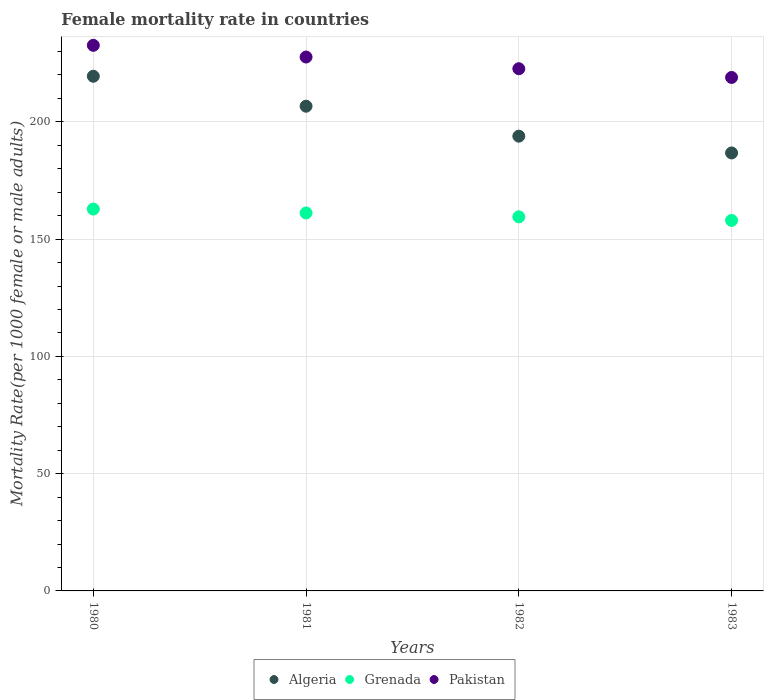Is the number of dotlines equal to the number of legend labels?
Your response must be concise. Yes. What is the female mortality rate in Algeria in 1980?
Offer a very short reply. 219.44. Across all years, what is the maximum female mortality rate in Pakistan?
Make the answer very short. 232.62. Across all years, what is the minimum female mortality rate in Algeria?
Provide a succinct answer. 186.74. In which year was the female mortality rate in Algeria maximum?
Ensure brevity in your answer.  1980. What is the total female mortality rate in Algeria in the graph?
Keep it short and to the point. 806.74. What is the difference between the female mortality rate in Grenada in 1981 and that in 1983?
Your answer should be very brief. 3.19. What is the difference between the female mortality rate in Grenada in 1981 and the female mortality rate in Algeria in 1980?
Make the answer very short. -58.28. What is the average female mortality rate in Grenada per year?
Provide a succinct answer. 160.36. In the year 1980, what is the difference between the female mortality rate in Algeria and female mortality rate in Grenada?
Offer a very short reply. 56.62. In how many years, is the female mortality rate in Pakistan greater than 90?
Provide a succinct answer. 4. What is the ratio of the female mortality rate in Grenada in 1980 to that in 1982?
Give a very brief answer. 1.02. What is the difference between the highest and the second highest female mortality rate in Grenada?
Make the answer very short. 1.66. What is the difference between the highest and the lowest female mortality rate in Grenada?
Make the answer very short. 4.84. In how many years, is the female mortality rate in Pakistan greater than the average female mortality rate in Pakistan taken over all years?
Your answer should be compact. 2. Is the sum of the female mortality rate in Grenada in 1980 and 1981 greater than the maximum female mortality rate in Algeria across all years?
Make the answer very short. Yes. Is it the case that in every year, the sum of the female mortality rate in Algeria and female mortality rate in Grenada  is greater than the female mortality rate in Pakistan?
Provide a succinct answer. Yes. Is the female mortality rate in Algeria strictly greater than the female mortality rate in Pakistan over the years?
Provide a succinct answer. No. How many years are there in the graph?
Your answer should be compact. 4. Are the values on the major ticks of Y-axis written in scientific E-notation?
Offer a very short reply. No. Does the graph contain any zero values?
Offer a terse response. No. Does the graph contain grids?
Offer a terse response. Yes. Where does the legend appear in the graph?
Give a very brief answer. Bottom center. How many legend labels are there?
Your response must be concise. 3. How are the legend labels stacked?
Keep it short and to the point. Horizontal. What is the title of the graph?
Give a very brief answer. Female mortality rate in countries. Does "China" appear as one of the legend labels in the graph?
Ensure brevity in your answer.  No. What is the label or title of the Y-axis?
Keep it short and to the point. Mortality Rate(per 1000 female or male adults). What is the Mortality Rate(per 1000 female or male adults) of Algeria in 1980?
Offer a terse response. 219.44. What is the Mortality Rate(per 1000 female or male adults) of Grenada in 1980?
Offer a very short reply. 162.81. What is the Mortality Rate(per 1000 female or male adults) in Pakistan in 1980?
Offer a very short reply. 232.62. What is the Mortality Rate(per 1000 female or male adults) in Algeria in 1981?
Provide a succinct answer. 206.67. What is the Mortality Rate(per 1000 female or male adults) in Grenada in 1981?
Provide a succinct answer. 161.16. What is the Mortality Rate(per 1000 female or male adults) of Pakistan in 1981?
Make the answer very short. 227.63. What is the Mortality Rate(per 1000 female or male adults) in Algeria in 1982?
Make the answer very short. 193.89. What is the Mortality Rate(per 1000 female or male adults) of Grenada in 1982?
Make the answer very short. 159.5. What is the Mortality Rate(per 1000 female or male adults) of Pakistan in 1982?
Keep it short and to the point. 222.65. What is the Mortality Rate(per 1000 female or male adults) in Algeria in 1983?
Keep it short and to the point. 186.74. What is the Mortality Rate(per 1000 female or male adults) in Grenada in 1983?
Give a very brief answer. 157.97. What is the Mortality Rate(per 1000 female or male adults) in Pakistan in 1983?
Your response must be concise. 218.93. Across all years, what is the maximum Mortality Rate(per 1000 female or male adults) of Algeria?
Your response must be concise. 219.44. Across all years, what is the maximum Mortality Rate(per 1000 female or male adults) in Grenada?
Your answer should be very brief. 162.81. Across all years, what is the maximum Mortality Rate(per 1000 female or male adults) of Pakistan?
Offer a terse response. 232.62. Across all years, what is the minimum Mortality Rate(per 1000 female or male adults) in Algeria?
Your response must be concise. 186.74. Across all years, what is the minimum Mortality Rate(per 1000 female or male adults) of Grenada?
Provide a succinct answer. 157.97. Across all years, what is the minimum Mortality Rate(per 1000 female or male adults) of Pakistan?
Ensure brevity in your answer.  218.93. What is the total Mortality Rate(per 1000 female or male adults) in Algeria in the graph?
Offer a terse response. 806.74. What is the total Mortality Rate(per 1000 female or male adults) in Grenada in the graph?
Your answer should be compact. 641.44. What is the total Mortality Rate(per 1000 female or male adults) of Pakistan in the graph?
Keep it short and to the point. 901.84. What is the difference between the Mortality Rate(per 1000 female or male adults) of Algeria in 1980 and that in 1981?
Make the answer very short. 12.77. What is the difference between the Mortality Rate(per 1000 female or male adults) in Grenada in 1980 and that in 1981?
Make the answer very short. 1.66. What is the difference between the Mortality Rate(per 1000 female or male adults) in Pakistan in 1980 and that in 1981?
Keep it short and to the point. 4.99. What is the difference between the Mortality Rate(per 1000 female or male adults) of Algeria in 1980 and that in 1982?
Ensure brevity in your answer.  25.55. What is the difference between the Mortality Rate(per 1000 female or male adults) of Grenada in 1980 and that in 1982?
Your answer should be very brief. 3.31. What is the difference between the Mortality Rate(per 1000 female or male adults) in Pakistan in 1980 and that in 1982?
Your answer should be compact. 9.97. What is the difference between the Mortality Rate(per 1000 female or male adults) of Algeria in 1980 and that in 1983?
Keep it short and to the point. 32.7. What is the difference between the Mortality Rate(per 1000 female or male adults) of Grenada in 1980 and that in 1983?
Provide a short and direct response. 4.84. What is the difference between the Mortality Rate(per 1000 female or male adults) in Pakistan in 1980 and that in 1983?
Give a very brief answer. 13.69. What is the difference between the Mortality Rate(per 1000 female or male adults) of Algeria in 1981 and that in 1982?
Your response must be concise. 12.77. What is the difference between the Mortality Rate(per 1000 female or male adults) of Grenada in 1981 and that in 1982?
Your answer should be compact. 1.66. What is the difference between the Mortality Rate(per 1000 female or male adults) of Pakistan in 1981 and that in 1982?
Give a very brief answer. 4.99. What is the difference between the Mortality Rate(per 1000 female or male adults) of Algeria in 1981 and that in 1983?
Give a very brief answer. 19.93. What is the difference between the Mortality Rate(per 1000 female or male adults) in Grenada in 1981 and that in 1983?
Make the answer very short. 3.19. What is the difference between the Mortality Rate(per 1000 female or male adults) of Pakistan in 1981 and that in 1983?
Provide a short and direct response. 8.7. What is the difference between the Mortality Rate(per 1000 female or male adults) in Algeria in 1982 and that in 1983?
Your response must be concise. 7.16. What is the difference between the Mortality Rate(per 1000 female or male adults) of Grenada in 1982 and that in 1983?
Your response must be concise. 1.53. What is the difference between the Mortality Rate(per 1000 female or male adults) in Pakistan in 1982 and that in 1983?
Give a very brief answer. 3.72. What is the difference between the Mortality Rate(per 1000 female or male adults) in Algeria in 1980 and the Mortality Rate(per 1000 female or male adults) in Grenada in 1981?
Keep it short and to the point. 58.28. What is the difference between the Mortality Rate(per 1000 female or male adults) of Algeria in 1980 and the Mortality Rate(per 1000 female or male adults) of Pakistan in 1981?
Your response must be concise. -8.2. What is the difference between the Mortality Rate(per 1000 female or male adults) in Grenada in 1980 and the Mortality Rate(per 1000 female or male adults) in Pakistan in 1981?
Your answer should be compact. -64.82. What is the difference between the Mortality Rate(per 1000 female or male adults) of Algeria in 1980 and the Mortality Rate(per 1000 female or male adults) of Grenada in 1982?
Make the answer very short. 59.94. What is the difference between the Mortality Rate(per 1000 female or male adults) in Algeria in 1980 and the Mortality Rate(per 1000 female or male adults) in Pakistan in 1982?
Provide a short and direct response. -3.21. What is the difference between the Mortality Rate(per 1000 female or male adults) of Grenada in 1980 and the Mortality Rate(per 1000 female or male adults) of Pakistan in 1982?
Offer a very short reply. -59.83. What is the difference between the Mortality Rate(per 1000 female or male adults) in Algeria in 1980 and the Mortality Rate(per 1000 female or male adults) in Grenada in 1983?
Give a very brief answer. 61.47. What is the difference between the Mortality Rate(per 1000 female or male adults) in Algeria in 1980 and the Mortality Rate(per 1000 female or male adults) in Pakistan in 1983?
Your answer should be very brief. 0.51. What is the difference between the Mortality Rate(per 1000 female or male adults) of Grenada in 1980 and the Mortality Rate(per 1000 female or male adults) of Pakistan in 1983?
Offer a terse response. -56.12. What is the difference between the Mortality Rate(per 1000 female or male adults) of Algeria in 1981 and the Mortality Rate(per 1000 female or male adults) of Grenada in 1982?
Your response must be concise. 47.16. What is the difference between the Mortality Rate(per 1000 female or male adults) of Algeria in 1981 and the Mortality Rate(per 1000 female or male adults) of Pakistan in 1982?
Make the answer very short. -15.98. What is the difference between the Mortality Rate(per 1000 female or male adults) of Grenada in 1981 and the Mortality Rate(per 1000 female or male adults) of Pakistan in 1982?
Offer a terse response. -61.49. What is the difference between the Mortality Rate(per 1000 female or male adults) in Algeria in 1981 and the Mortality Rate(per 1000 female or male adults) in Grenada in 1983?
Keep it short and to the point. 48.7. What is the difference between the Mortality Rate(per 1000 female or male adults) of Algeria in 1981 and the Mortality Rate(per 1000 female or male adults) of Pakistan in 1983?
Provide a succinct answer. -12.27. What is the difference between the Mortality Rate(per 1000 female or male adults) in Grenada in 1981 and the Mortality Rate(per 1000 female or male adults) in Pakistan in 1983?
Offer a terse response. -57.77. What is the difference between the Mortality Rate(per 1000 female or male adults) of Algeria in 1982 and the Mortality Rate(per 1000 female or male adults) of Grenada in 1983?
Your answer should be compact. 35.92. What is the difference between the Mortality Rate(per 1000 female or male adults) of Algeria in 1982 and the Mortality Rate(per 1000 female or male adults) of Pakistan in 1983?
Offer a terse response. -25.04. What is the difference between the Mortality Rate(per 1000 female or male adults) in Grenada in 1982 and the Mortality Rate(per 1000 female or male adults) in Pakistan in 1983?
Offer a terse response. -59.43. What is the average Mortality Rate(per 1000 female or male adults) in Algeria per year?
Provide a short and direct response. 201.68. What is the average Mortality Rate(per 1000 female or male adults) in Grenada per year?
Provide a succinct answer. 160.36. What is the average Mortality Rate(per 1000 female or male adults) in Pakistan per year?
Keep it short and to the point. 225.46. In the year 1980, what is the difference between the Mortality Rate(per 1000 female or male adults) in Algeria and Mortality Rate(per 1000 female or male adults) in Grenada?
Make the answer very short. 56.62. In the year 1980, what is the difference between the Mortality Rate(per 1000 female or male adults) in Algeria and Mortality Rate(per 1000 female or male adults) in Pakistan?
Offer a terse response. -13.18. In the year 1980, what is the difference between the Mortality Rate(per 1000 female or male adults) in Grenada and Mortality Rate(per 1000 female or male adults) in Pakistan?
Offer a terse response. -69.81. In the year 1981, what is the difference between the Mortality Rate(per 1000 female or male adults) in Algeria and Mortality Rate(per 1000 female or male adults) in Grenada?
Give a very brief answer. 45.51. In the year 1981, what is the difference between the Mortality Rate(per 1000 female or male adults) of Algeria and Mortality Rate(per 1000 female or male adults) of Pakistan?
Make the answer very short. -20.97. In the year 1981, what is the difference between the Mortality Rate(per 1000 female or male adults) in Grenada and Mortality Rate(per 1000 female or male adults) in Pakistan?
Your answer should be compact. -66.48. In the year 1982, what is the difference between the Mortality Rate(per 1000 female or male adults) of Algeria and Mortality Rate(per 1000 female or male adults) of Grenada?
Make the answer very short. 34.39. In the year 1982, what is the difference between the Mortality Rate(per 1000 female or male adults) of Algeria and Mortality Rate(per 1000 female or male adults) of Pakistan?
Provide a succinct answer. -28.75. In the year 1982, what is the difference between the Mortality Rate(per 1000 female or male adults) in Grenada and Mortality Rate(per 1000 female or male adults) in Pakistan?
Keep it short and to the point. -63.15. In the year 1983, what is the difference between the Mortality Rate(per 1000 female or male adults) in Algeria and Mortality Rate(per 1000 female or male adults) in Grenada?
Provide a succinct answer. 28.77. In the year 1983, what is the difference between the Mortality Rate(per 1000 female or male adults) of Algeria and Mortality Rate(per 1000 female or male adults) of Pakistan?
Your answer should be very brief. -32.19. In the year 1983, what is the difference between the Mortality Rate(per 1000 female or male adults) in Grenada and Mortality Rate(per 1000 female or male adults) in Pakistan?
Provide a succinct answer. -60.96. What is the ratio of the Mortality Rate(per 1000 female or male adults) in Algeria in 1980 to that in 1981?
Your answer should be very brief. 1.06. What is the ratio of the Mortality Rate(per 1000 female or male adults) in Grenada in 1980 to that in 1981?
Keep it short and to the point. 1.01. What is the ratio of the Mortality Rate(per 1000 female or male adults) of Pakistan in 1980 to that in 1981?
Your answer should be very brief. 1.02. What is the ratio of the Mortality Rate(per 1000 female or male adults) of Algeria in 1980 to that in 1982?
Your answer should be compact. 1.13. What is the ratio of the Mortality Rate(per 1000 female or male adults) of Grenada in 1980 to that in 1982?
Make the answer very short. 1.02. What is the ratio of the Mortality Rate(per 1000 female or male adults) of Pakistan in 1980 to that in 1982?
Your answer should be very brief. 1.04. What is the ratio of the Mortality Rate(per 1000 female or male adults) in Algeria in 1980 to that in 1983?
Provide a succinct answer. 1.18. What is the ratio of the Mortality Rate(per 1000 female or male adults) of Grenada in 1980 to that in 1983?
Keep it short and to the point. 1.03. What is the ratio of the Mortality Rate(per 1000 female or male adults) of Algeria in 1981 to that in 1982?
Your answer should be very brief. 1.07. What is the ratio of the Mortality Rate(per 1000 female or male adults) in Grenada in 1981 to that in 1982?
Offer a terse response. 1.01. What is the ratio of the Mortality Rate(per 1000 female or male adults) of Pakistan in 1981 to that in 1982?
Provide a succinct answer. 1.02. What is the ratio of the Mortality Rate(per 1000 female or male adults) of Algeria in 1981 to that in 1983?
Ensure brevity in your answer.  1.11. What is the ratio of the Mortality Rate(per 1000 female or male adults) of Grenada in 1981 to that in 1983?
Offer a very short reply. 1.02. What is the ratio of the Mortality Rate(per 1000 female or male adults) of Pakistan in 1981 to that in 1983?
Make the answer very short. 1.04. What is the ratio of the Mortality Rate(per 1000 female or male adults) of Algeria in 1982 to that in 1983?
Keep it short and to the point. 1.04. What is the ratio of the Mortality Rate(per 1000 female or male adults) of Grenada in 1982 to that in 1983?
Make the answer very short. 1.01. What is the ratio of the Mortality Rate(per 1000 female or male adults) of Pakistan in 1982 to that in 1983?
Offer a very short reply. 1.02. What is the difference between the highest and the second highest Mortality Rate(per 1000 female or male adults) of Algeria?
Provide a succinct answer. 12.77. What is the difference between the highest and the second highest Mortality Rate(per 1000 female or male adults) of Grenada?
Offer a very short reply. 1.66. What is the difference between the highest and the second highest Mortality Rate(per 1000 female or male adults) in Pakistan?
Provide a succinct answer. 4.99. What is the difference between the highest and the lowest Mortality Rate(per 1000 female or male adults) in Algeria?
Give a very brief answer. 32.7. What is the difference between the highest and the lowest Mortality Rate(per 1000 female or male adults) of Grenada?
Make the answer very short. 4.84. What is the difference between the highest and the lowest Mortality Rate(per 1000 female or male adults) of Pakistan?
Offer a very short reply. 13.69. 